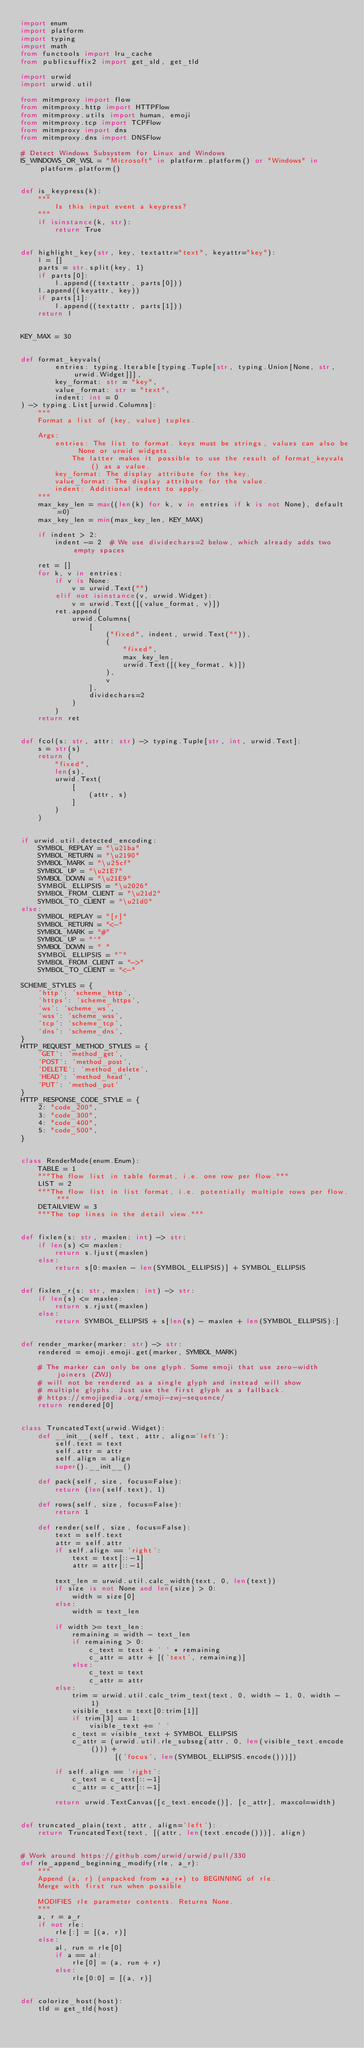Convert code to text. <code><loc_0><loc_0><loc_500><loc_500><_Python_>import enum
import platform
import typing
import math
from functools import lru_cache
from publicsuffix2 import get_sld, get_tld

import urwid
import urwid.util

from mitmproxy import flow
from mitmproxy.http import HTTPFlow
from mitmproxy.utils import human, emoji
from mitmproxy.tcp import TCPFlow
from mitmproxy import dns
from mitmproxy.dns import DNSFlow

# Detect Windows Subsystem for Linux and Windows
IS_WINDOWS_OR_WSL = "Microsoft" in platform.platform() or "Windows" in platform.platform()


def is_keypress(k):
    """
        Is this input event a keypress?
    """
    if isinstance(k, str):
        return True


def highlight_key(str, key, textattr="text", keyattr="key"):
    l = []
    parts = str.split(key, 1)
    if parts[0]:
        l.append((textattr, parts[0]))
    l.append((keyattr, key))
    if parts[1]:
        l.append((textattr, parts[1]))
    return l


KEY_MAX = 30


def format_keyvals(
        entries: typing.Iterable[typing.Tuple[str, typing.Union[None, str, urwid.Widget]]],
        key_format: str = "key",
        value_format: str = "text",
        indent: int = 0
) -> typing.List[urwid.Columns]:
    """
    Format a list of (key, value) tuples.

    Args:
        entries: The list to format. keys must be strings, values can also be None or urwid widgets.
            The latter makes it possible to use the result of format_keyvals() as a value.
        key_format: The display attribute for the key.
        value_format: The display attribute for the value.
        indent: Additional indent to apply.
    """
    max_key_len = max((len(k) for k, v in entries if k is not None), default=0)
    max_key_len = min(max_key_len, KEY_MAX)

    if indent > 2:
        indent -= 2  # We use dividechars=2 below, which already adds two empty spaces

    ret = []
    for k, v in entries:
        if v is None:
            v = urwid.Text("")
        elif not isinstance(v, urwid.Widget):
            v = urwid.Text([(value_format, v)])
        ret.append(
            urwid.Columns(
                [
                    ("fixed", indent, urwid.Text("")),
                    (
                        "fixed",
                        max_key_len,
                        urwid.Text([(key_format, k)])
                    ),
                    v
                ],
                dividechars=2
            )
        )
    return ret


def fcol(s: str, attr: str) -> typing.Tuple[str, int, urwid.Text]:
    s = str(s)
    return (
        "fixed",
        len(s),
        urwid.Text(
            [
                (attr, s)
            ]
        )
    )


if urwid.util.detected_encoding:
    SYMBOL_REPLAY = "\u21ba"
    SYMBOL_RETURN = "\u2190"
    SYMBOL_MARK = "\u25cf"
    SYMBOL_UP = "\u21E7"
    SYMBOL_DOWN = "\u21E9"
    SYMBOL_ELLIPSIS = "\u2026"
    SYMBOL_FROM_CLIENT = "\u21d2"
    SYMBOL_TO_CLIENT = "\u21d0"
else:
    SYMBOL_REPLAY = "[r]"
    SYMBOL_RETURN = "<-"
    SYMBOL_MARK = "#"
    SYMBOL_UP = "^"
    SYMBOL_DOWN = " "
    SYMBOL_ELLIPSIS = "~"
    SYMBOL_FROM_CLIENT = "->"
    SYMBOL_TO_CLIENT = "<-"

SCHEME_STYLES = {
    'http': 'scheme_http',
    'https': 'scheme_https',
    'ws': 'scheme_ws',
    'wss': 'scheme_wss',
    'tcp': 'scheme_tcp',
    'dns': 'scheme_dns',
}
HTTP_REQUEST_METHOD_STYLES = {
    'GET': 'method_get',
    'POST': 'method_post',
    'DELETE': 'method_delete',
    'HEAD': 'method_head',
    'PUT': 'method_put'
}
HTTP_RESPONSE_CODE_STYLE = {
    2: "code_200",
    3: "code_300",
    4: "code_400",
    5: "code_500",
}


class RenderMode(enum.Enum):
    TABLE = 1
    """The flow list in table format, i.e. one row per flow."""
    LIST = 2
    """The flow list in list format, i.e. potentially multiple rows per flow."""
    DETAILVIEW = 3
    """The top lines in the detail view."""


def fixlen(s: str, maxlen: int) -> str:
    if len(s) <= maxlen:
        return s.ljust(maxlen)
    else:
        return s[0:maxlen - len(SYMBOL_ELLIPSIS)] + SYMBOL_ELLIPSIS


def fixlen_r(s: str, maxlen: int) -> str:
    if len(s) <= maxlen:
        return s.rjust(maxlen)
    else:
        return SYMBOL_ELLIPSIS + s[len(s) - maxlen + len(SYMBOL_ELLIPSIS):]


def render_marker(marker: str) -> str:
    rendered = emoji.emoji.get(marker, SYMBOL_MARK)

    # The marker can only be one glyph. Some emoji that use zero-width joiners (ZWJ)
    # will not be rendered as a single glyph and instead will show
    # multiple glyphs. Just use the first glyph as a fallback.
    # https://emojipedia.org/emoji-zwj-sequence/
    return rendered[0]


class TruncatedText(urwid.Widget):
    def __init__(self, text, attr, align='left'):
        self.text = text
        self.attr = attr
        self.align = align
        super().__init__()

    def pack(self, size, focus=False):
        return (len(self.text), 1)

    def rows(self, size, focus=False):
        return 1

    def render(self, size, focus=False):
        text = self.text
        attr = self.attr
        if self.align == 'right':
            text = text[::-1]
            attr = attr[::-1]

        text_len = urwid.util.calc_width(text, 0, len(text))
        if size is not None and len(size) > 0:
            width = size[0]
        else:
            width = text_len

        if width >= text_len:
            remaining = width - text_len
            if remaining > 0:
                c_text = text + ' ' * remaining
                c_attr = attr + [('text', remaining)]
            else:
                c_text = text
                c_attr = attr
        else:
            trim = urwid.util.calc_trim_text(text, 0, width - 1, 0, width - 1)
            visible_text = text[0:trim[1]]
            if trim[3] == 1:
                visible_text += ' '
            c_text = visible_text + SYMBOL_ELLIPSIS
            c_attr = (urwid.util.rle_subseg(attr, 0, len(visible_text.encode())) +
                      [('focus', len(SYMBOL_ELLIPSIS.encode()))])

        if self.align == 'right':
            c_text = c_text[::-1]
            c_attr = c_attr[::-1]

        return urwid.TextCanvas([c_text.encode()], [c_attr], maxcol=width)


def truncated_plain(text, attr, align='left'):
    return TruncatedText(text, [(attr, len(text.encode()))], align)


# Work around https://github.com/urwid/urwid/pull/330
def rle_append_beginning_modify(rle, a_r):
    """
    Append (a, r) (unpacked from *a_r*) to BEGINNING of rle.
    Merge with first run when possible

    MODIFIES rle parameter contents. Returns None.
    """
    a, r = a_r
    if not rle:
        rle[:] = [(a, r)]
    else:
        al, run = rle[0]
        if a == al:
            rle[0] = (a, run + r)
        else:
            rle[0:0] = [(a, r)]


def colorize_host(host):
    tld = get_tld(host)</code> 